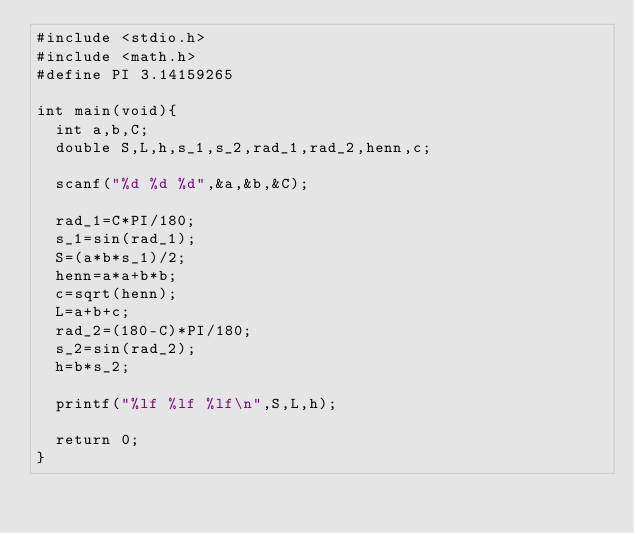Convert code to text. <code><loc_0><loc_0><loc_500><loc_500><_C_>#include <stdio.h>
#include <math.h>
#define PI 3.14159265

int main(void){
	int a,b,C;
	double S,L,h,s_1,s_2,rad_1,rad_2,henn,c;

	scanf("%d %d %d",&a,&b,&C);

	rad_1=C*PI/180;
	s_1=sin(rad_1);
	S=(a*b*s_1)/2;
	henn=a*a+b*b;
	c=sqrt(henn);
	L=a+b+c;
	rad_2=(180-C)*PI/180;
	s_2=sin(rad_2);
	h=b*s_2;

	printf("%lf %lf %lf\n",S,L,h);

	return 0;
}</code> 